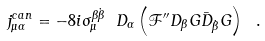Convert formula to latex. <formula><loc_0><loc_0><loc_500><loc_500>j ^ { c a n } _ { \mu \alpha } = - 8 i \sigma _ { \mu } ^ { \beta { \dot { \beta } } } \ D _ { \alpha } \left ( { \mathcal { F } } ^ { \prime \prime } D _ { \beta } G { \bar { D } } _ { \dot { \beta } } G \right ) \ .</formula> 